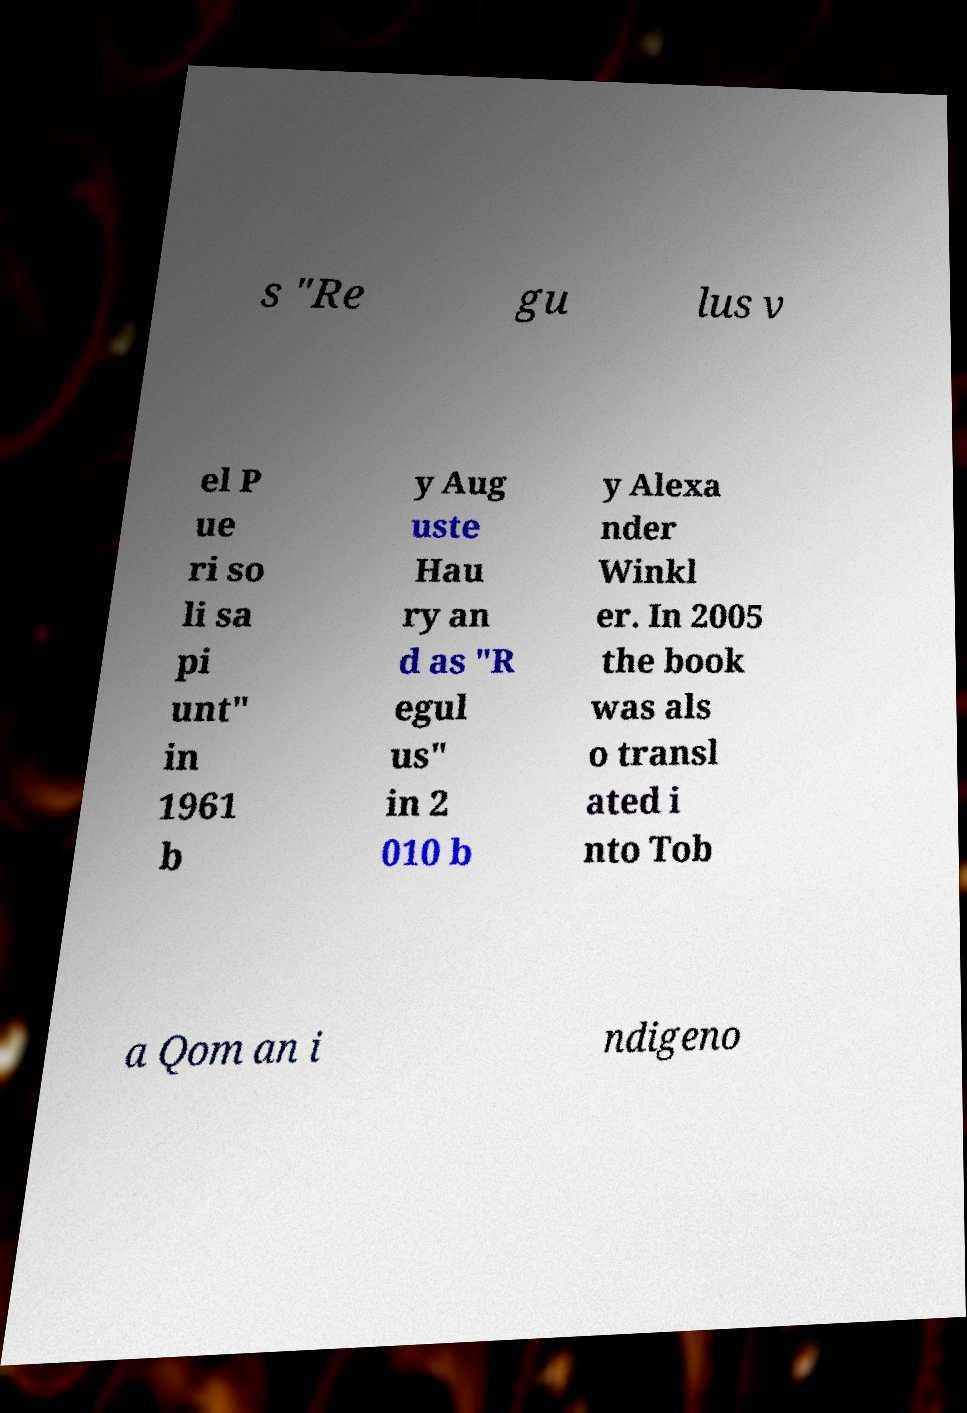Please identify and transcribe the text found in this image. s "Re gu lus v el P ue ri so li sa pi unt" in 1961 b y Aug uste Hau ry an d as "R egul us" in 2 010 b y Alexa nder Winkl er. In 2005 the book was als o transl ated i nto Tob a Qom an i ndigeno 